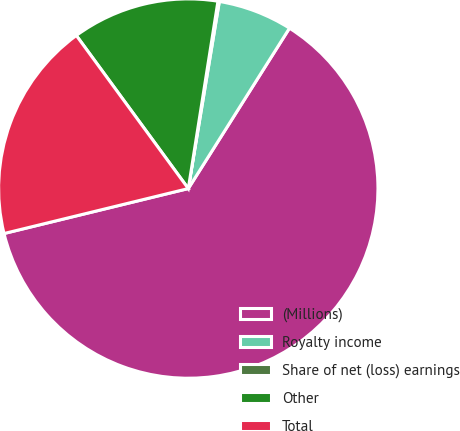Convert chart. <chart><loc_0><loc_0><loc_500><loc_500><pie_chart><fcel>(Millions)<fcel>Royalty income<fcel>Share of net (loss) earnings<fcel>Other<fcel>Total<nl><fcel>62.24%<fcel>6.34%<fcel>0.12%<fcel>12.55%<fcel>18.76%<nl></chart> 